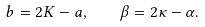<formula> <loc_0><loc_0><loc_500><loc_500>b = 2 K - a , \quad \beta = 2 \kappa - \alpha .</formula> 